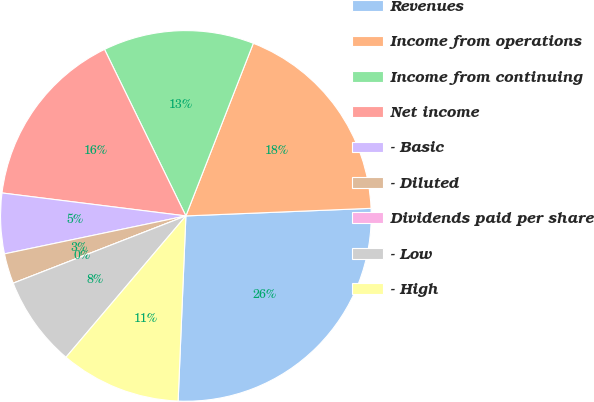<chart> <loc_0><loc_0><loc_500><loc_500><pie_chart><fcel>Revenues<fcel>Income from operations<fcel>Income from continuing<fcel>Net income<fcel>- Basic<fcel>- Diluted<fcel>Dividends paid per share<fcel>- Low<fcel>- High<nl><fcel>26.32%<fcel>18.42%<fcel>13.16%<fcel>15.79%<fcel>5.26%<fcel>2.63%<fcel>0.0%<fcel>7.89%<fcel>10.53%<nl></chart> 